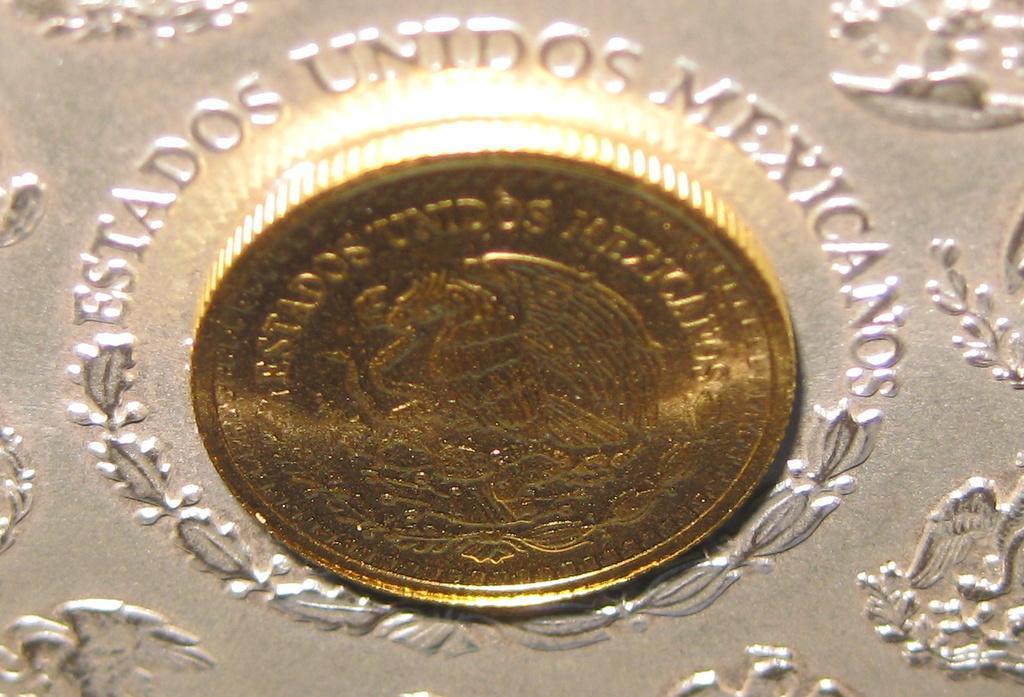In one or two sentences, can you explain what this image depicts? In this picture we can see a coin,some text,some design on a platform. 